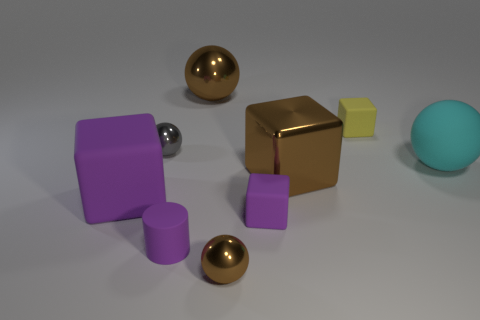How many other objects are there of the same size as the yellow rubber cube?
Your answer should be compact. 4. The tiny matte block in front of the large metallic block is what color?
Offer a very short reply. Purple. Do the tiny yellow object behind the small rubber cylinder and the brown block have the same material?
Ensure brevity in your answer.  No. What number of purple objects are to the right of the cylinder and on the left side of the small brown metallic sphere?
Ensure brevity in your answer.  0. The sphere behind the gray metal object that is behind the large brown object in front of the small yellow block is what color?
Keep it short and to the point. Brown. What number of other things are the same shape as the cyan thing?
Your answer should be compact. 3. There is a brown sphere behind the small yellow thing; is there a rubber object that is left of it?
Offer a terse response. Yes. How many matte objects are either yellow objects or gray things?
Offer a very short reply. 1. There is a small thing that is both in front of the large brown cube and behind the purple cylinder; what is it made of?
Your answer should be compact. Rubber. Are there any small gray metallic balls that are to the left of the purple block that is to the right of the brown thing in front of the purple cylinder?
Provide a succinct answer. Yes. 